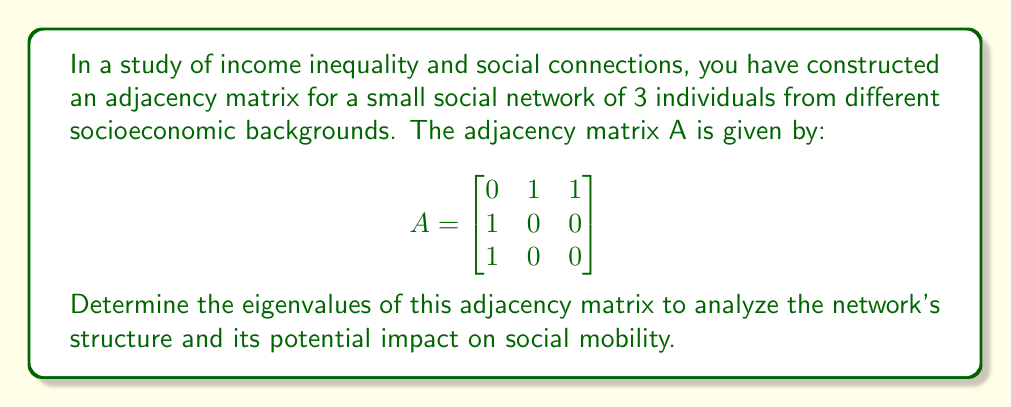Help me with this question. To find the eigenvalues of the adjacency matrix A, we need to solve the characteristic equation:

1) First, we set up the characteristic equation:
   $det(A - \lambda I) = 0$

2) Expand the determinant:
   $$det\begin{pmatrix}
   -\lambda & 1 & 1 \\
   1 & -\lambda & 0 \\
   1 & 0 & -\lambda
   \end{pmatrix} = 0$$

3) Calculate the determinant:
   $-\lambda(-\lambda^2) + 1(1) + 1(0) - 1(0) - 1(-\lambda) - (-\lambda)(0) = 0$

4) Simplify:
   $\lambda^3 - \lambda - 1 = 0$

5) This cubic equation can be solved by factoring or using the cubic formula. By inspection, we can see that $\lambda = 1$ is a solution.

6) Factoring out $(\lambda - 1)$:
   $(\lambda - 1)(\lambda^2 + \lambda - 1) = 0$

7) Using the quadratic formula for $\lambda^2 + \lambda - 1 = 0$:
   $\lambda = \frac{-1 \pm \sqrt{1^2 + 4(1)}}{2} = \frac{-1 \pm \sqrt{5}}{2}$

Therefore, the eigenvalues are:
$\lambda_1 = 1$
$\lambda_2 = \frac{-1 + \sqrt{5}}{2} \approx 0.618$
$\lambda_3 = \frac{-1 - \sqrt{5}}{2} \approx -1.618$

These eigenvalues provide insights into the network's structure, with the largest eigenvalue (1) indicating the overall connectivity, and the others revealing additional structural properties that may influence social mobility within this small network.
Answer: $\lambda_1 = 1$, $\lambda_2 = \frac{-1 + \sqrt{5}}{2}$, $\lambda_3 = \frac{-1 - \sqrt{5}}{2}$ 